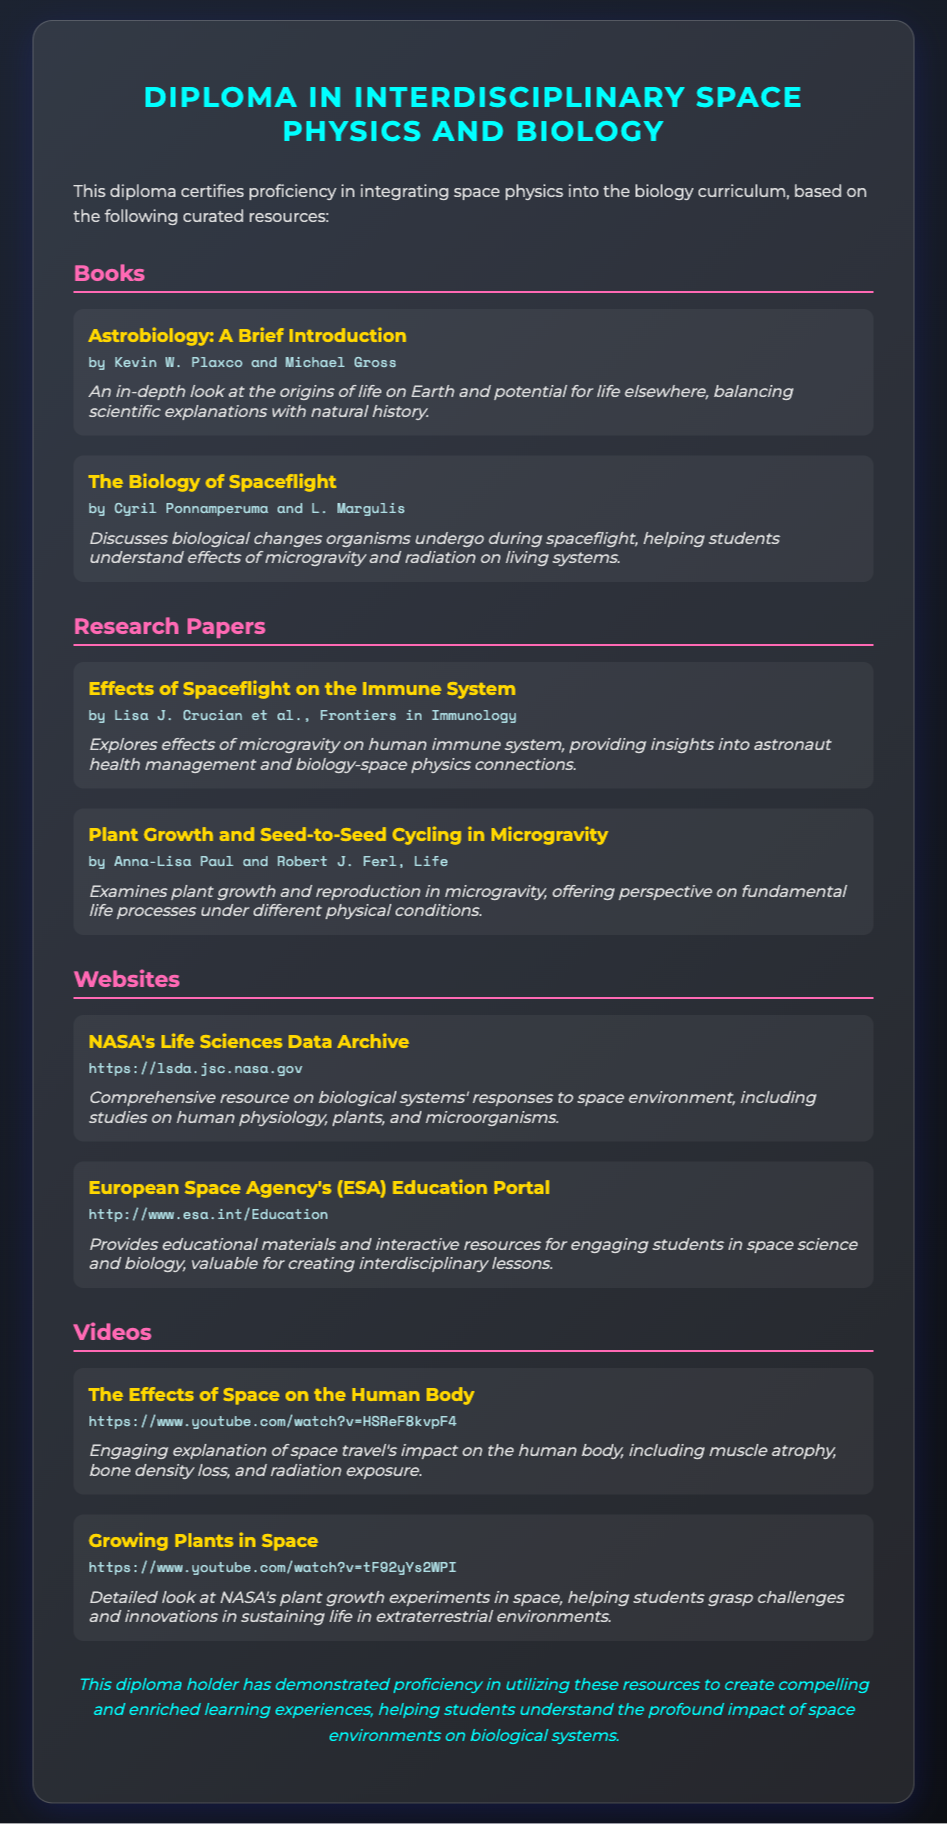What is the title of the diploma? The title of the diploma is prominently displayed at the top of the document.
Answer: Diploma in Interdisciplinary Space Physics and Biology Who are the authors of the book "Astrobiology: A Brief Introduction"? The authors are listed under the title of the book, specifying the individuals involved in the authorship.
Answer: Kevin W. Plaxco and Michael Gross What website provides educational materials related to space science and biology? The resource list includes URLs for specific websites providing valuable educational materials.
Answer: European Space Agency's (ESA) Education Portal What is the main focus of the research paper titled "Effects of Spaceflight on the Immune System"? The annotation of the research paper summarizes the key area of study it addresses regarding the effects of spaceflight.
Answer: Effects of microgravity on human immune system How many videos are listed in the document? The number of videos can be determined by counting the entries under the Videos section.
Answer: 2 What is the format of the provided resources? The format can be understood by observing the structure of sections and how they are categorized.
Answer: Books, Research Papers, Websites, Videos What type of resource is "The Biology of Spaceflight"? The categorization of the resource in the document helps identify its type.
Answer: Book Which author contributed to the paper "Plant Growth and Seed-to-Seed Cycling in Microgravity"? The authorship of the research paper is indicated along with its title, allowing identification of the contributor.
Answer: Anna-Lisa Paul and Robert J. Ferl 